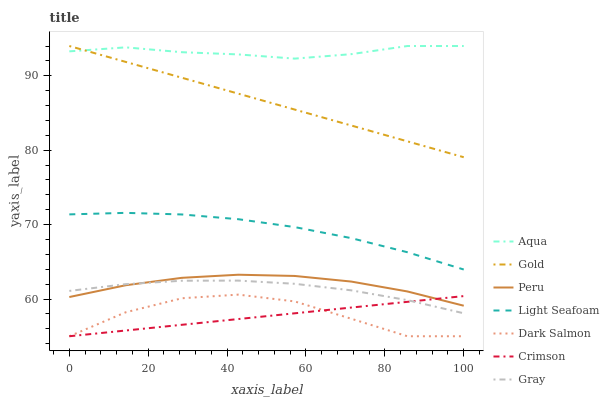Does Crimson have the minimum area under the curve?
Answer yes or no. Yes. Does Aqua have the maximum area under the curve?
Answer yes or no. Yes. Does Gold have the minimum area under the curve?
Answer yes or no. No. Does Gold have the maximum area under the curve?
Answer yes or no. No. Is Crimson the smoothest?
Answer yes or no. Yes. Is Dark Salmon the roughest?
Answer yes or no. Yes. Is Gold the smoothest?
Answer yes or no. No. Is Gold the roughest?
Answer yes or no. No. Does Dark Salmon have the lowest value?
Answer yes or no. Yes. Does Gold have the lowest value?
Answer yes or no. No. Does Aqua have the highest value?
Answer yes or no. Yes. Does Dark Salmon have the highest value?
Answer yes or no. No. Is Crimson less than Aqua?
Answer yes or no. Yes. Is Peru greater than Dark Salmon?
Answer yes or no. Yes. Does Dark Salmon intersect Crimson?
Answer yes or no. Yes. Is Dark Salmon less than Crimson?
Answer yes or no. No. Is Dark Salmon greater than Crimson?
Answer yes or no. No. Does Crimson intersect Aqua?
Answer yes or no. No. 